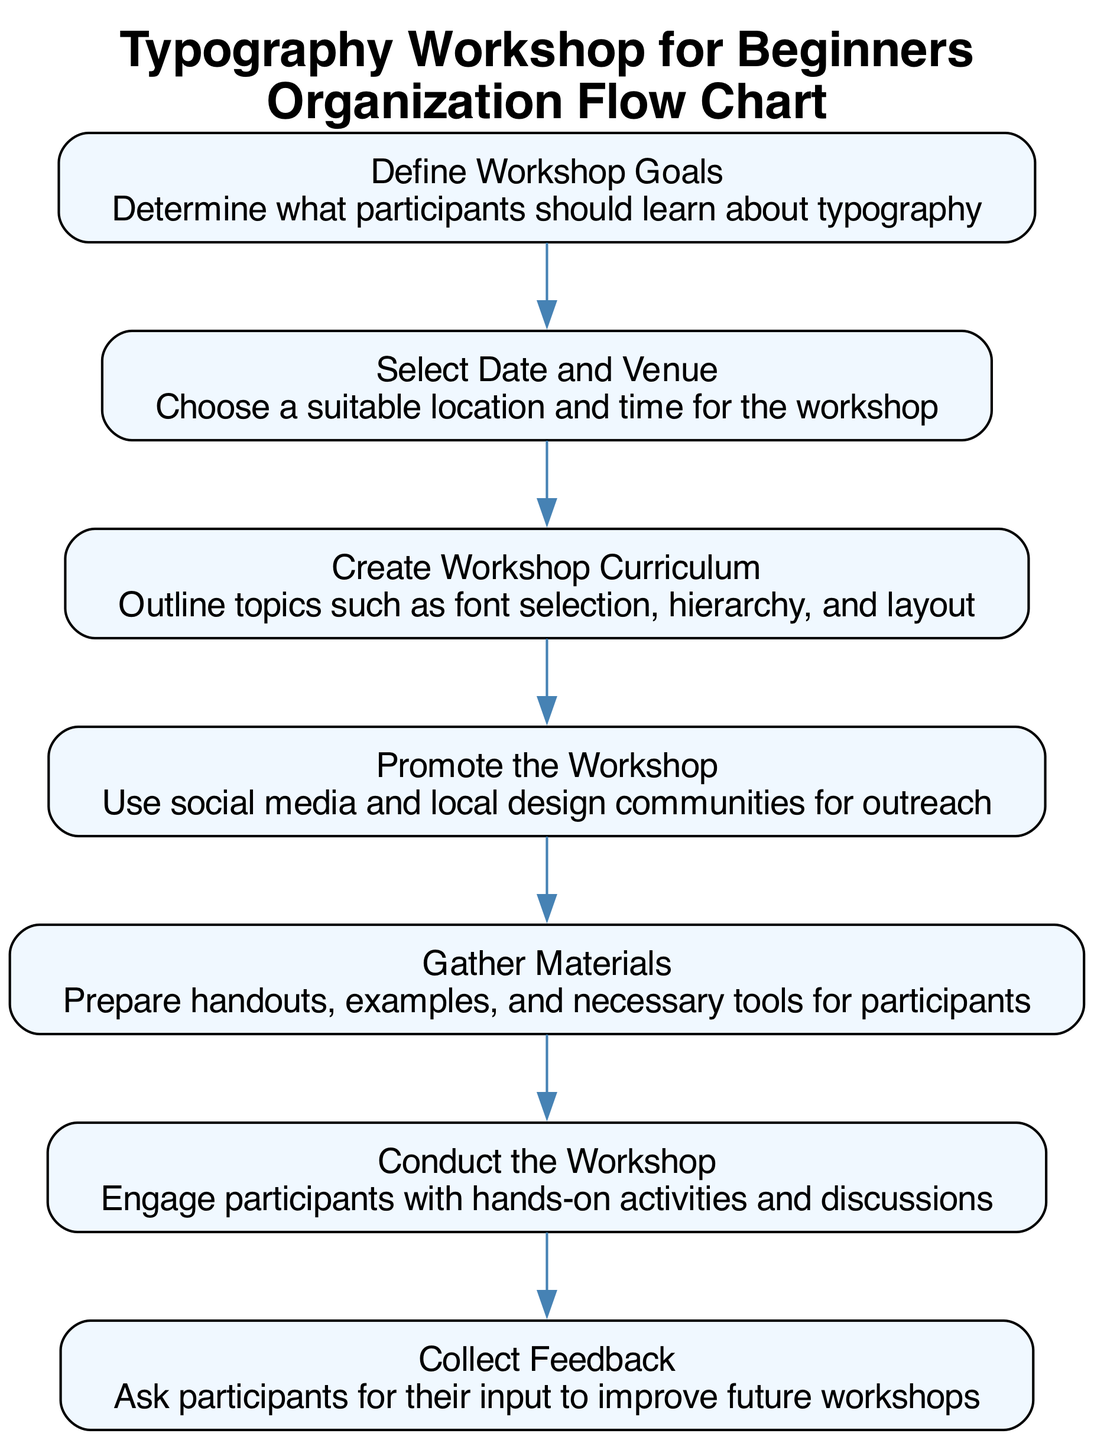What is the first step in the flow chart? The first step in the flow chart is 'Define Workshop Goals', which is the initial node presented at the top of the diagram.
Answer: Define Workshop Goals How many steps are there in total? The flow chart outlines seven distinct steps as represented by the seven nodes in the diagram, each leading to the next.
Answer: 7 What is the last step listed in the flow chart? The final step presented in the flow chart is 'Collect Feedback', located at the bottom of the diagram, indicating the conclusion of the workflow.
Answer: Collect Feedback Which step comes after 'Select Date and Venue'? Following 'Select Date and Venue', the diagram illustrates 'Create Workshop Curriculum' as the next step, showing the progression in organizing the workshop.
Answer: Create Workshop Curriculum How many connections are there in the flow chart? The flow chart features six connections or edges, linking each consecutive step together, from the first to the last step.
Answer: 6 What are the topics included in the 'Create Workshop Curriculum'? The 'Create Workshop Curriculum' step outlines specific topics such as font selection, hierarchy, and layout, which are essential for teaching typography.
Answer: Font selection, hierarchy, and layout Which two steps are connected directly? 'Promote the Workshop' is directly connected to 'Gather Materials', indicating the sequence of tasks in preparing the workshop after promotion.
Answer: Promote the Workshop and Gather Materials What action is suggested in the 'Conduct the Workshop' step? In the 'Conduct the Workshop' step, it suggests engaging participants, which emphasizes interactive learning during the workshop itself.
Answer: Engage participants What is the purpose of the 'Collect Feedback' step? The purpose of the 'Collect Feedback' step is to gather participants' input, allowing for improvements and refinements of future workshops.
Answer: Gather participants' input 